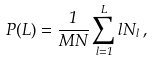<formula> <loc_0><loc_0><loc_500><loc_500>P ( L ) = \frac { 1 } { M N } \sum _ { l = 1 } ^ { L } l N _ { l } \, ,</formula> 